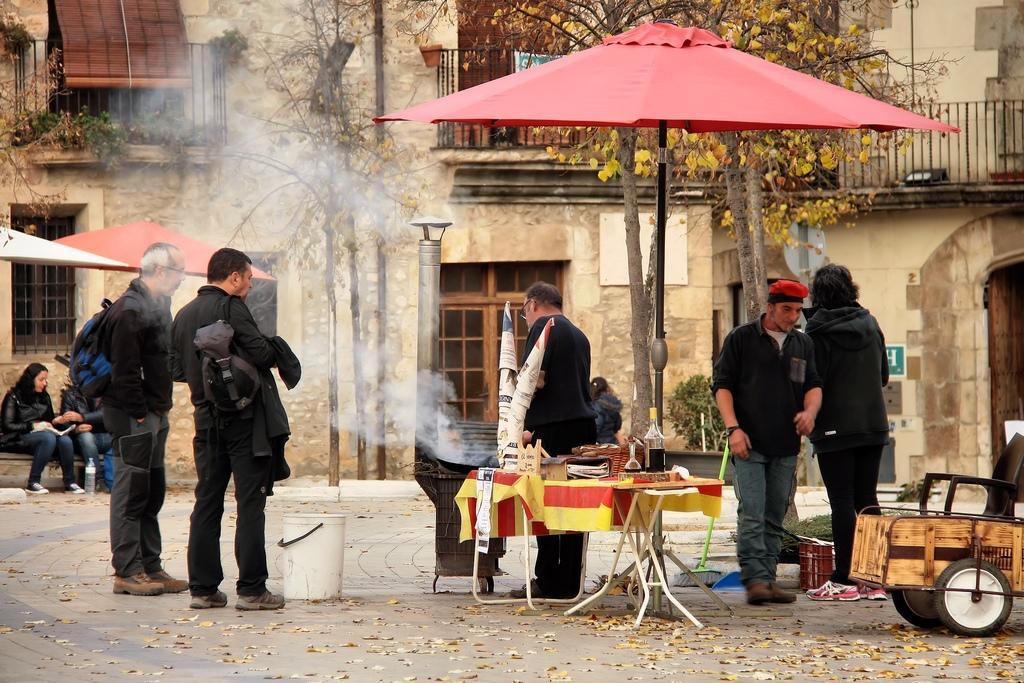Can you describe this image briefly? There is a group of people. This is the outside of the house. On the left side we have a person. He's wearing a bag. On the left side we have women. She is sitting. There is tree,table. There is a some wooden products on a table. On the right side we have a person. He is wearing a red cap. 